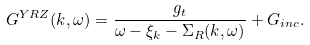Convert formula to latex. <formula><loc_0><loc_0><loc_500><loc_500>G ^ { Y R Z } ( { k } , \omega ) = \frac { g _ { t } } { \omega - \xi _ { k } - \Sigma _ { R } ( { k } , \omega ) } + G _ { i n c } .</formula> 